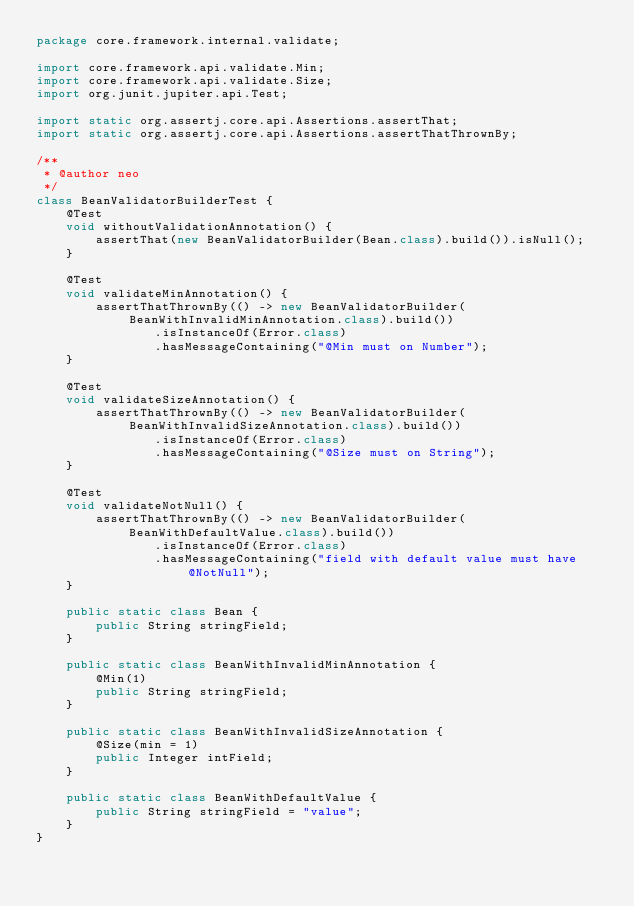Convert code to text. <code><loc_0><loc_0><loc_500><loc_500><_Java_>package core.framework.internal.validate;

import core.framework.api.validate.Min;
import core.framework.api.validate.Size;
import org.junit.jupiter.api.Test;

import static org.assertj.core.api.Assertions.assertThat;
import static org.assertj.core.api.Assertions.assertThatThrownBy;

/**
 * @author neo
 */
class BeanValidatorBuilderTest {
    @Test
    void withoutValidationAnnotation() {
        assertThat(new BeanValidatorBuilder(Bean.class).build()).isNull();
    }

    @Test
    void validateMinAnnotation() {
        assertThatThrownBy(() -> new BeanValidatorBuilder(BeanWithInvalidMinAnnotation.class).build())
                .isInstanceOf(Error.class)
                .hasMessageContaining("@Min must on Number");
    }

    @Test
    void validateSizeAnnotation() {
        assertThatThrownBy(() -> new BeanValidatorBuilder(BeanWithInvalidSizeAnnotation.class).build())
                .isInstanceOf(Error.class)
                .hasMessageContaining("@Size must on String");
    }

    @Test
    void validateNotNull() {
        assertThatThrownBy(() -> new BeanValidatorBuilder(BeanWithDefaultValue.class).build())
                .isInstanceOf(Error.class)
                .hasMessageContaining("field with default value must have @NotNull");
    }

    public static class Bean {
        public String stringField;
    }

    public static class BeanWithInvalidMinAnnotation {
        @Min(1)
        public String stringField;
    }

    public static class BeanWithInvalidSizeAnnotation {
        @Size(min = 1)
        public Integer intField;
    }

    public static class BeanWithDefaultValue {
        public String stringField = "value";
    }
}
</code> 